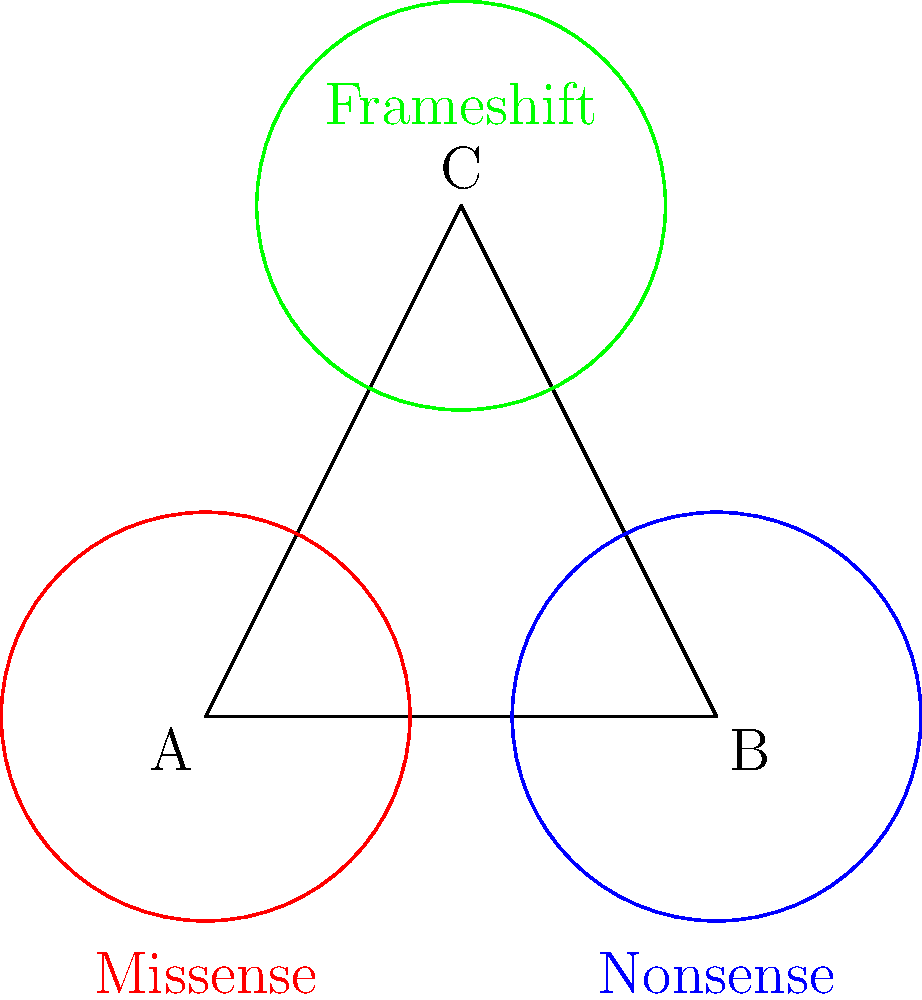In a study of genetic mutations associated with eye diseases, researchers have classified mutations into three main types: missense, nonsense, and frameshift. The Venn diagram above represents the distribution of these mutations in a sample population. If we consider each region of the diagram as a subset of the total population, how many distinct subsets (including the empty set and the entire set) can be formed using the group theory concept of the power set? To solve this problem, we need to apply the concept of power sets from group theory to the Venn diagram of genetic mutations. Let's break it down step-by-step:

1. First, we need to identify the number of distinct regions in the Venn diagram. There are:
   - 3 regions with single mutations (A, B, C)
   - 3 regions with overlaps of two mutations (AB, BC, AC)
   - 1 region with all three mutations (ABC)
   - 1 region outside all circles (empty set)

   Total: 8 distinct regions

2. In group theory, the power set of a set S is the set of all subsets of S, including the empty set and S itself.

3. The number of elements in a power set is given by the formula: $2^n$, where n is the number of elements in the original set.

4. In our case, we have 8 distinct regions, so n = 8.

5. Therefore, the number of distinct subsets (elements in the power set) is:

   $2^8 = 256$

This means that there are 256 possible ways to combine these regions, including:
- The empty set (no mutations)
- Each individual region
- Combinations of regions
- The entire set (all mutations)
Answer: 256 